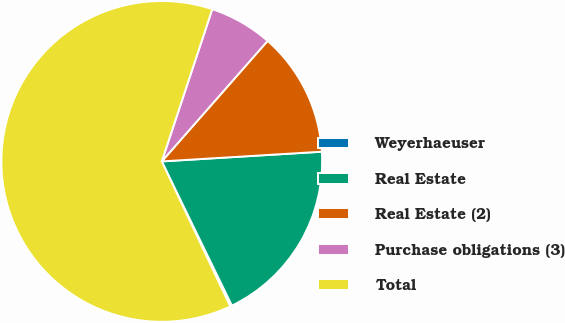<chart> <loc_0><loc_0><loc_500><loc_500><pie_chart><fcel>Weyerhaeuser<fcel>Real Estate<fcel>Real Estate (2)<fcel>Purchase obligations (3)<fcel>Total<nl><fcel>0.18%<fcel>18.76%<fcel>12.57%<fcel>6.37%<fcel>62.13%<nl></chart> 